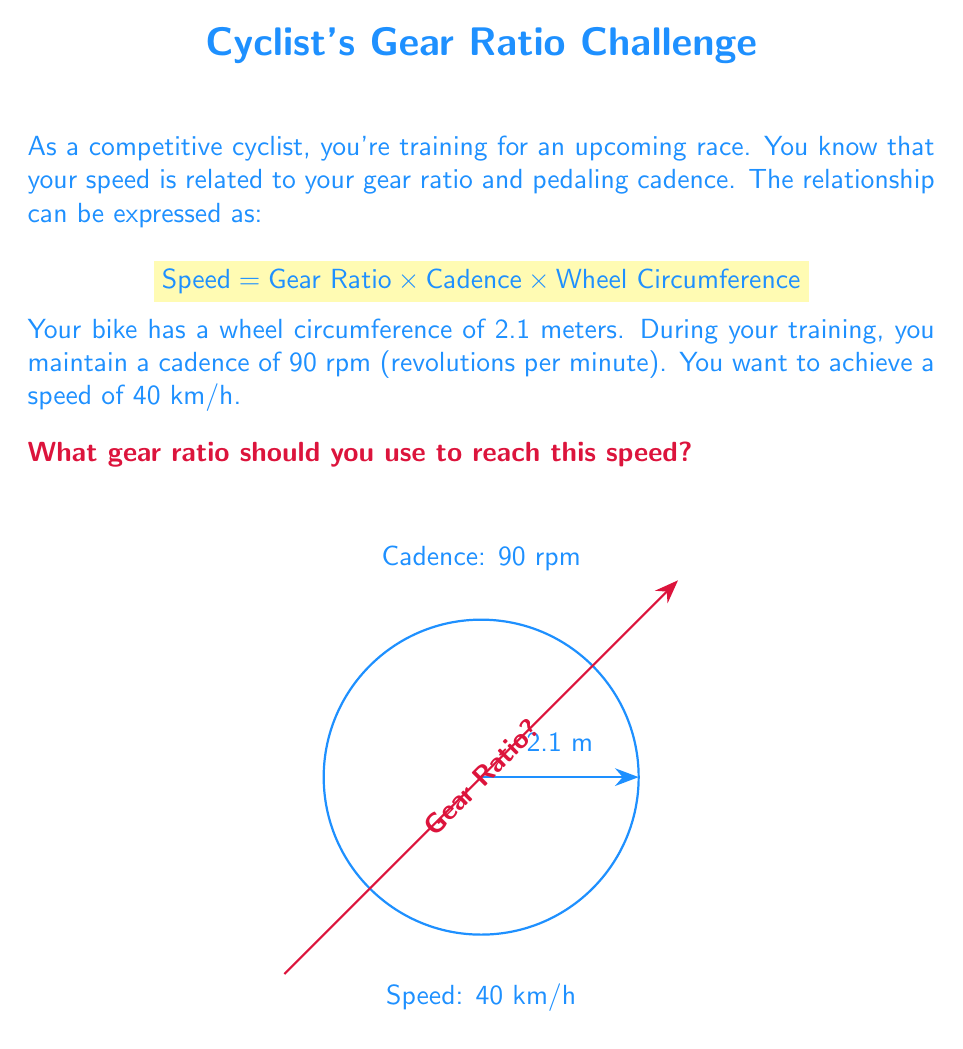Provide a solution to this math problem. Let's approach this step-by-step:

1) First, we need to convert all units to be consistent:
   - Speed: 40 km/h = $\frac{40000 \text{ m}}{3600 \text{ s}} = \frac{10}{0.9} \text{ m/s}$
   - Cadence: 90 rpm = $\frac{90}{60} = 1.5 \text{ rps (revolutions per second)}$
   - Wheel Circumference: 2.1 m

2) Now, let's use the given formula:
   $$ \text{Speed} = \text{Gear Ratio} \times \text{Cadence} \times \text{Wheel Circumference} $$

3) Substitute the known values:
   $$ \frac{10}{0.9} = \text{Gear Ratio} \times 1.5 \times 2.1 $$

4) Simplify the right side:
   $$ \frac{10}{0.9} = \text{Gear Ratio} \times 3.15 $$

5) Solve for Gear Ratio:
   $$ \text{Gear Ratio} = \frac{10}{0.9 \times 3.15} = \frac{10}{2.835} $$

6) Simplify:
   $$ \text{Gear Ratio} \approx 3.53 $$

Therefore, to achieve a speed of 40 km/h with a cadence of 90 rpm and a wheel circumference of 2.1 m, you need a gear ratio of approximately 3.53.
Answer: 3.53 